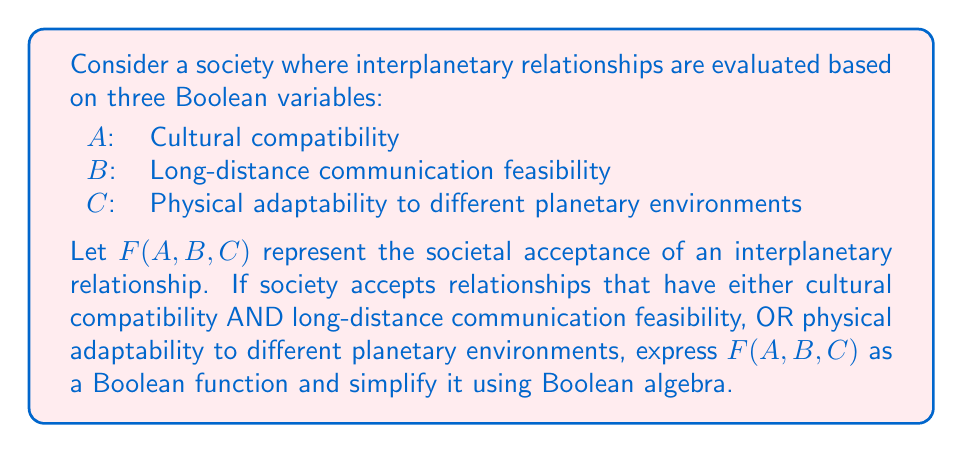Show me your answer to this math problem. 1. First, let's express the given conditions as a Boolean function:
   $F(A,B,C) = (A \cdot B) + C$

2. To simplify this function, we can use the distributive law of Boolean algebra:
   $F(A,B,C) = (A \cdot B) + (C \cdot 1)$

3. Using the identity property of multiplication (1 is the identity element):
   $F(A,B,C) = (A \cdot B) + (C \cdot (A + A'))$

4. Applying the distributive law again:
   $F(A,B,C) = (A \cdot B) + (C \cdot A) + (C \cdot A')$

5. Rearranging terms:
   $F(A,B,C) = A \cdot (B + C) + (C \cdot A')$

6. This is the simplified Boolean function representing the societal acceptance of interplanetary relationships based on the given criteria.
Answer: $F(A,B,C) = A \cdot (B + C) + (C \cdot A')$ 